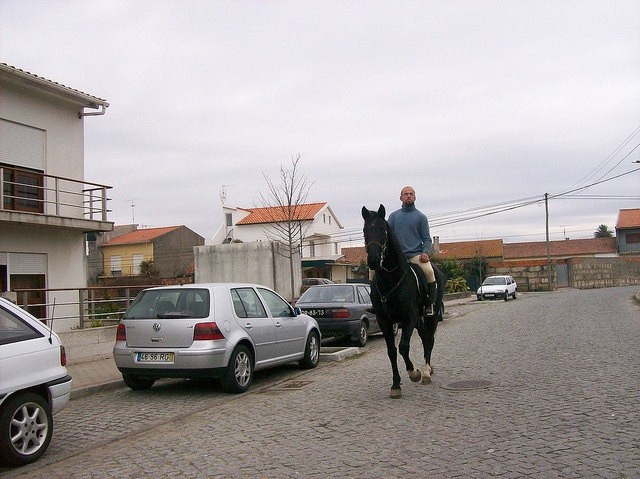Describe the objects in this image and their specific colors. I can see car in lavender, gray, darkgray, black, and lightgray tones, car in lavender, black, darkgray, lightgray, and gray tones, horse in lavender, black, gray, and darkgray tones, car in lavender, black, darkgray, and gray tones, and people in lavender, black, gray, and blue tones in this image. 